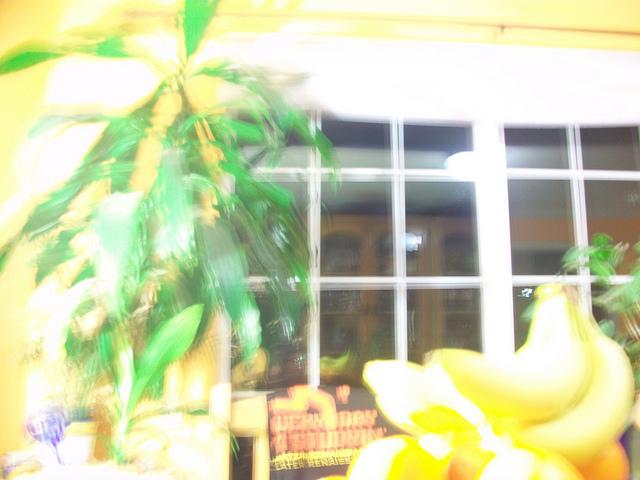What can be seen through the window?
Keep it brief. Cabinet. Is the tree dead?
Short answer required. No. Is there fruit in this picture?
Answer briefly. Yes. 